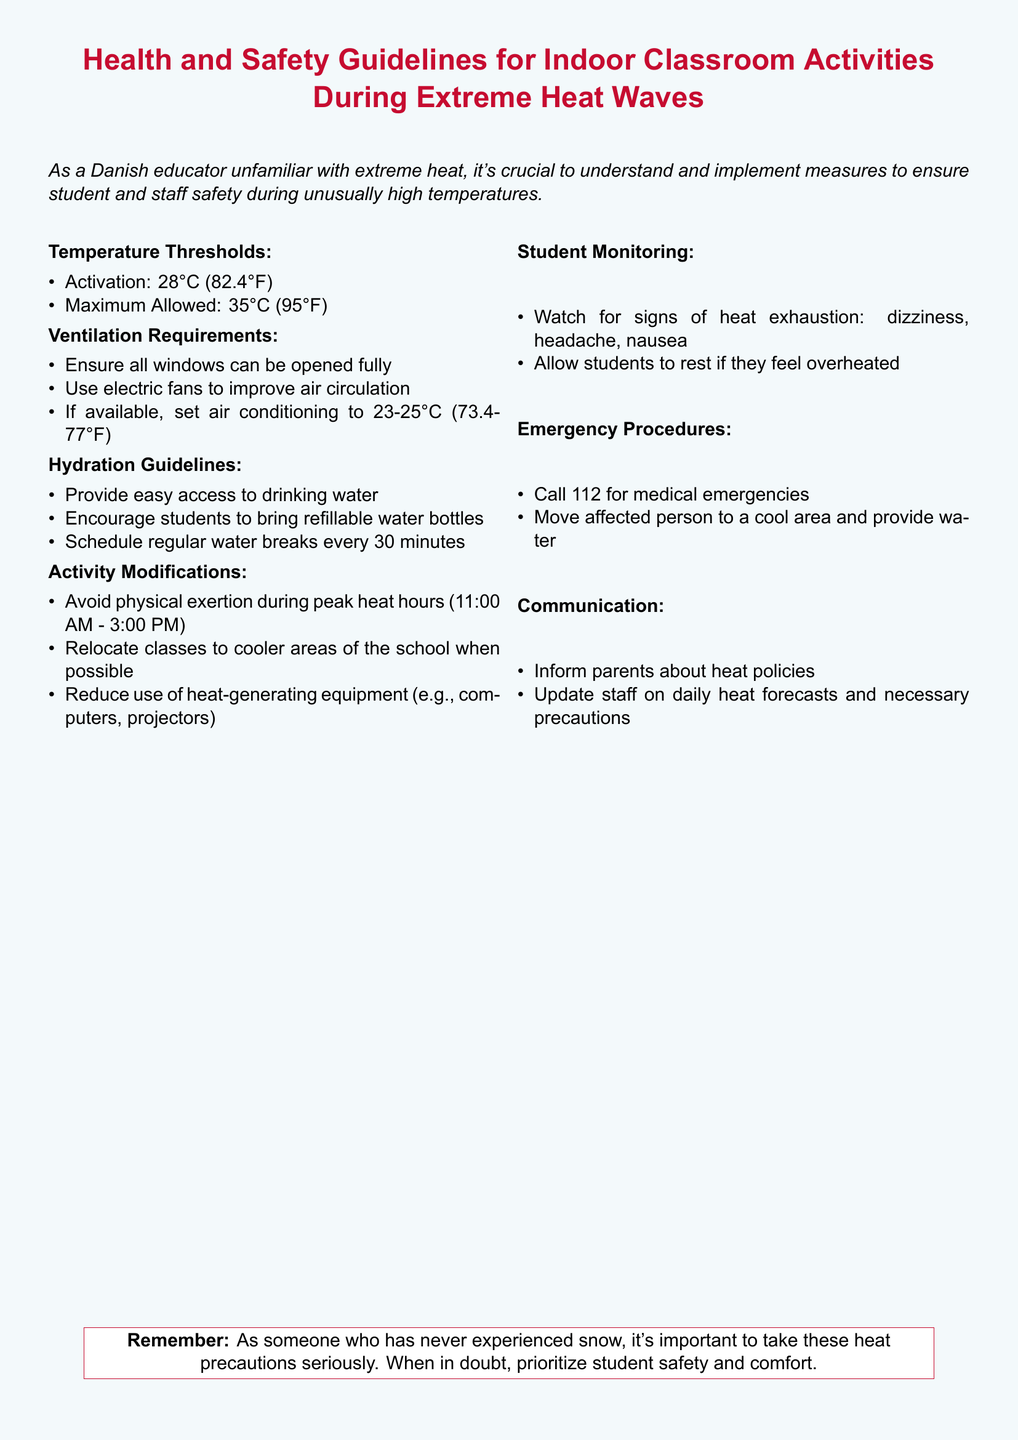What is the activation temperature? The activation temperature is specified as the point at which the heat wave measures take effect, which is 28°C.
Answer: 28°C What is the maximum allowed temperature? The maximum temperature indicates the upper limit for classroom activities during extreme heat waves, which is 35°C.
Answer: 35°C What should be done to improve air circulation? The document lists using electric fans as one of the methods to enhance ventilation in the classroom.
Answer: Use electric fans How often should students take water breaks? Regular water breaks help maintain hydration, and the guideline states these breaks should occur every 30 minutes.
Answer: Every 30 minutes What signs indicate heat exhaustion? The document specifies signs of heat exhaustion that should be monitored in students, including dizziness and nausea.
Answer: Dizziness, nausea What should be avoided during peak heat hours? Physical exertion is recommended to be avoided during the hours when temperatures are highest to ensure student safety.
Answer: Physical exertion What should be done in case of a medical emergency? The policy outlines the first response step, which is to call 112 for medical emergencies.
Answer: Call 112 What items should students bring for hydration? The guidelines encourage students to bring refillable water bottles for easy access to hydration.
Answer: Refillable water bottles What is the communication guideline regarding parents? Parents should be informed about the heat policies as part of the communication guidelines in the document.
Answer: Inform parents 